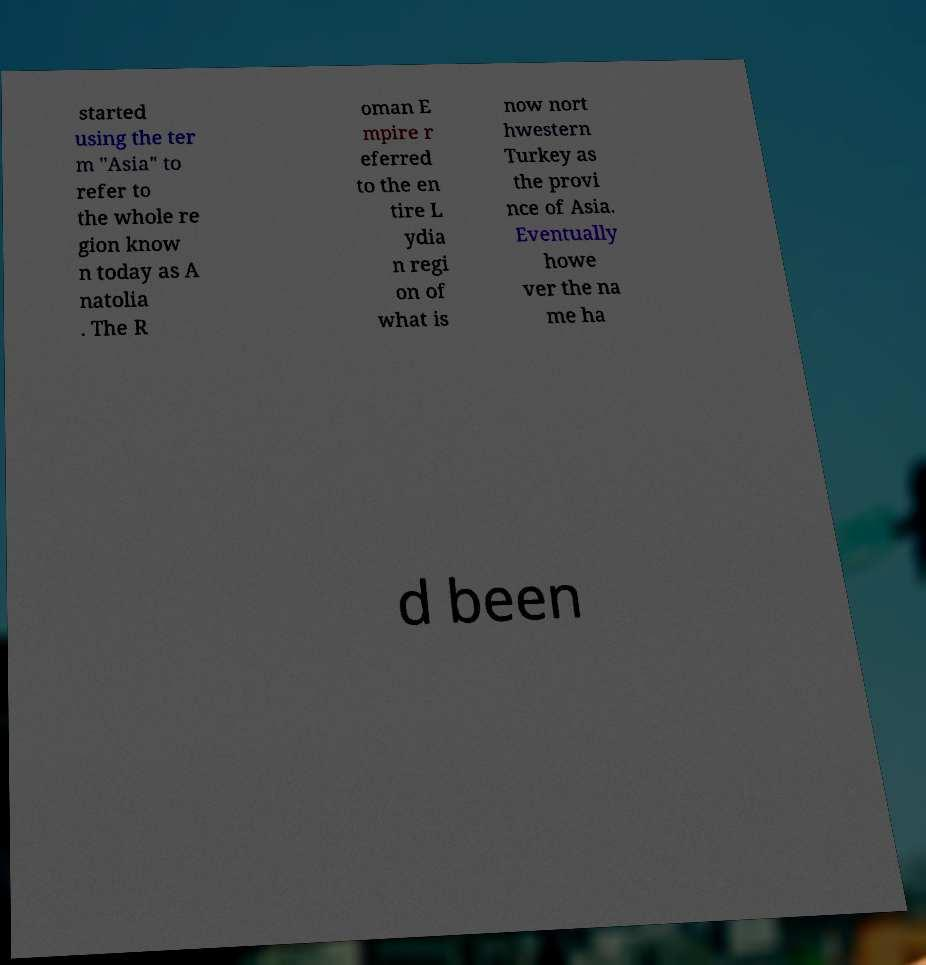Could you assist in decoding the text presented in this image and type it out clearly? started using the ter m "Asia" to refer to the whole re gion know n today as A natolia . The R oman E mpire r eferred to the en tire L ydia n regi on of what is now nort hwestern Turkey as the provi nce of Asia. Eventually howe ver the na me ha d been 